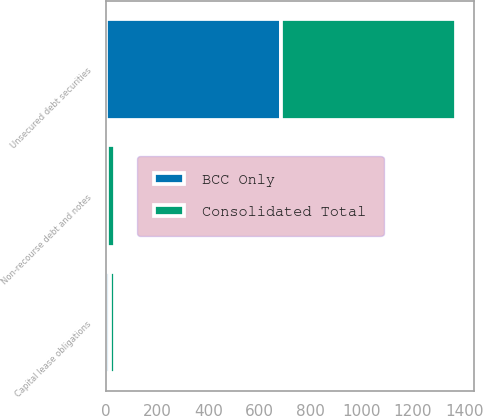Convert chart to OTSL. <chart><loc_0><loc_0><loc_500><loc_500><stacked_bar_chart><ecel><fcel>Unsecured debt securities<fcel>Capital lease obligations<fcel>Non-recourse debt and notes<nl><fcel>Consolidated Total<fcel>685<fcel>17<fcel>31<nl><fcel>BCC Only<fcel>685<fcel>16<fcel>5<nl></chart> 